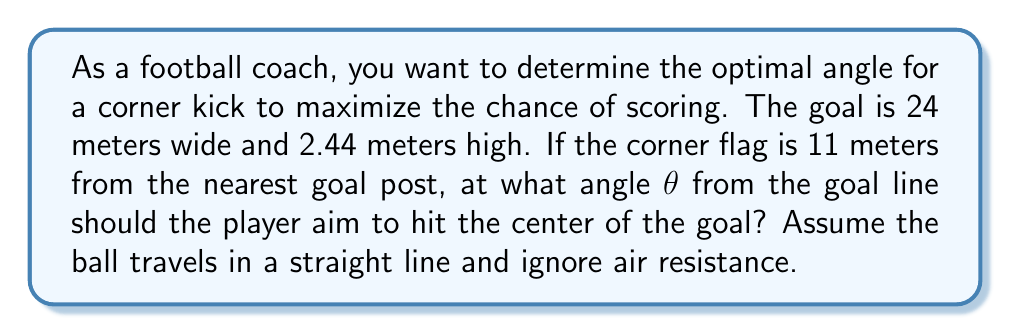Provide a solution to this math problem. Let's approach this step-by-step:

1) First, we need to visualize the problem. Let's create a diagram:

[asy]
unitsize(0.2cm);
draw((0,0)--(24,0)--(24,2.44)--(0,2.44)--cycle);
draw((0,0)--(-11,0));
draw((-11,0)--(12,1.22));
label("θ", (-9.5,0.5), NE);
label("11m", (-5.5,-1), S);
label("24m", (12,-1), S);
label("2.44m", (25,1.22), E);
dot((-11,0));
dot((12,1.22));
[/asy]

2) We can treat this as a right-angled triangle problem. The corner flag is at the right angle.

3) We know the adjacent side of the triangle (11 meters) and need to find the opposite side and the angle.

4) The opposite side is the distance from the goal line to the center of the goal:
   $$ \text{opposite} = \sqrt{12^2 + 1.22^2} \approx 12.06 \text{ meters} $$

5) Now we can use the arctangent function to find the angle:

   $$ \theta = \arctan(\frac{\text{opposite}}{\text{adjacent}}) $$

6) Substituting our values:

   $$ \theta = \arctan(\frac{12.06}{11}) $$

7) Calculate:

   $$ \theta \approx 47.64° $$

8) Convert to radians if necessary:

   $$ \theta \approx 0.83 \text{ radians} $$
Answer: $\theta \approx 47.64°$ or $0.83$ radians 